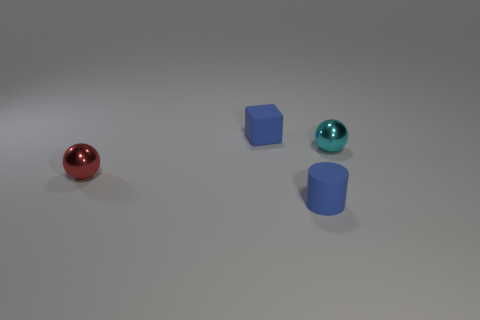Is the cylinder the same color as the tiny rubber block?
Offer a very short reply. Yes. There is a tiny cyan thing; is it the same shape as the tiny blue thing behind the small cyan ball?
Offer a very short reply. No. The tiny rubber thing behind the cyan object on the right side of the matte object that is on the right side of the rubber cube is what color?
Offer a very short reply. Blue. What number of things are balls that are behind the red metal ball or spheres that are on the right side of the red metallic object?
Ensure brevity in your answer.  1. What number of other things are there of the same color as the small block?
Offer a terse response. 1. There is a tiny object in front of the tiny red object; is it the same shape as the red metal object?
Your answer should be very brief. No. Are there fewer tiny rubber blocks that are to the left of the block than small blue matte cylinders?
Provide a short and direct response. Yes. Are there any tiny red objects made of the same material as the block?
Your response must be concise. No. What material is the cube that is the same size as the rubber cylinder?
Your response must be concise. Rubber. Are there fewer blue rubber things in front of the small red metallic sphere than cyan metallic balls left of the rubber cylinder?
Give a very brief answer. No. 